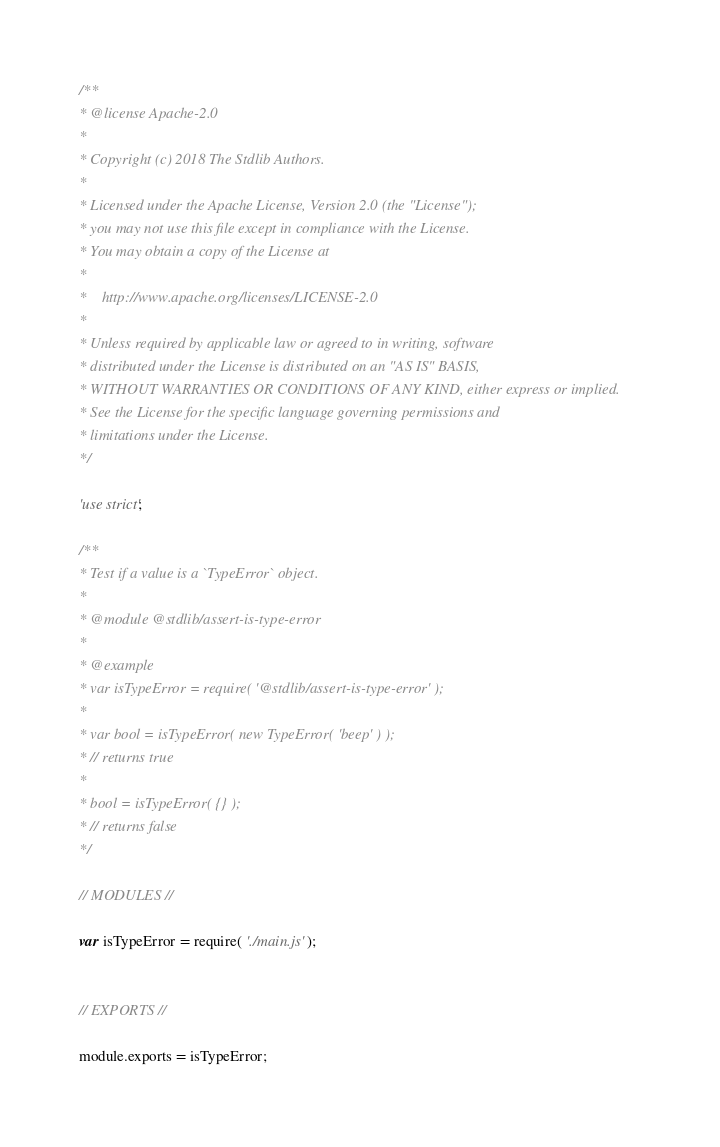<code> <loc_0><loc_0><loc_500><loc_500><_JavaScript_>/**
* @license Apache-2.0
*
* Copyright (c) 2018 The Stdlib Authors.
*
* Licensed under the Apache License, Version 2.0 (the "License");
* you may not use this file except in compliance with the License.
* You may obtain a copy of the License at
*
*    http://www.apache.org/licenses/LICENSE-2.0
*
* Unless required by applicable law or agreed to in writing, software
* distributed under the License is distributed on an "AS IS" BASIS,
* WITHOUT WARRANTIES OR CONDITIONS OF ANY KIND, either express or implied.
* See the License for the specific language governing permissions and
* limitations under the License.
*/

'use strict';

/**
* Test if a value is a `TypeError` object.
*
* @module @stdlib/assert-is-type-error
*
* @example
* var isTypeError = require( '@stdlib/assert-is-type-error' );
*
* var bool = isTypeError( new TypeError( 'beep' ) );
* // returns true
*
* bool = isTypeError( {} );
* // returns false
*/

// MODULES //

var isTypeError = require( './main.js' );


// EXPORTS //

module.exports = isTypeError;
</code> 